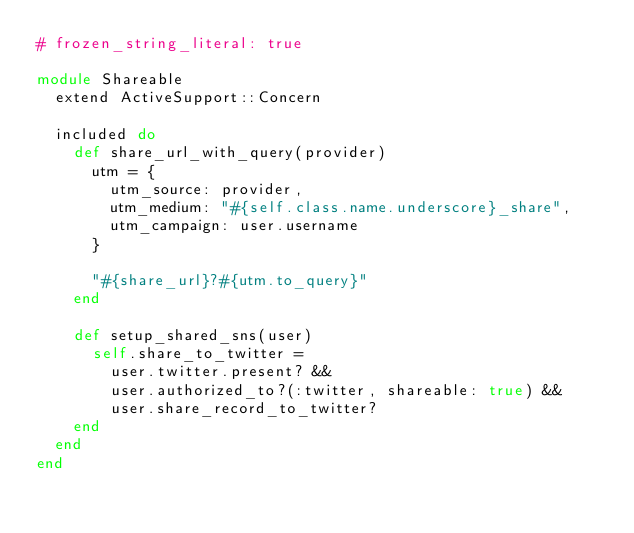<code> <loc_0><loc_0><loc_500><loc_500><_Ruby_># frozen_string_literal: true

module Shareable
  extend ActiveSupport::Concern

  included do
    def share_url_with_query(provider)
      utm = {
        utm_source: provider,
        utm_medium: "#{self.class.name.underscore}_share",
        utm_campaign: user.username
      }

      "#{share_url}?#{utm.to_query}"
    end

    def setup_shared_sns(user)
      self.share_to_twitter =
        user.twitter.present? &&
        user.authorized_to?(:twitter, shareable: true) &&
        user.share_record_to_twitter?
    end
  end
end
</code> 